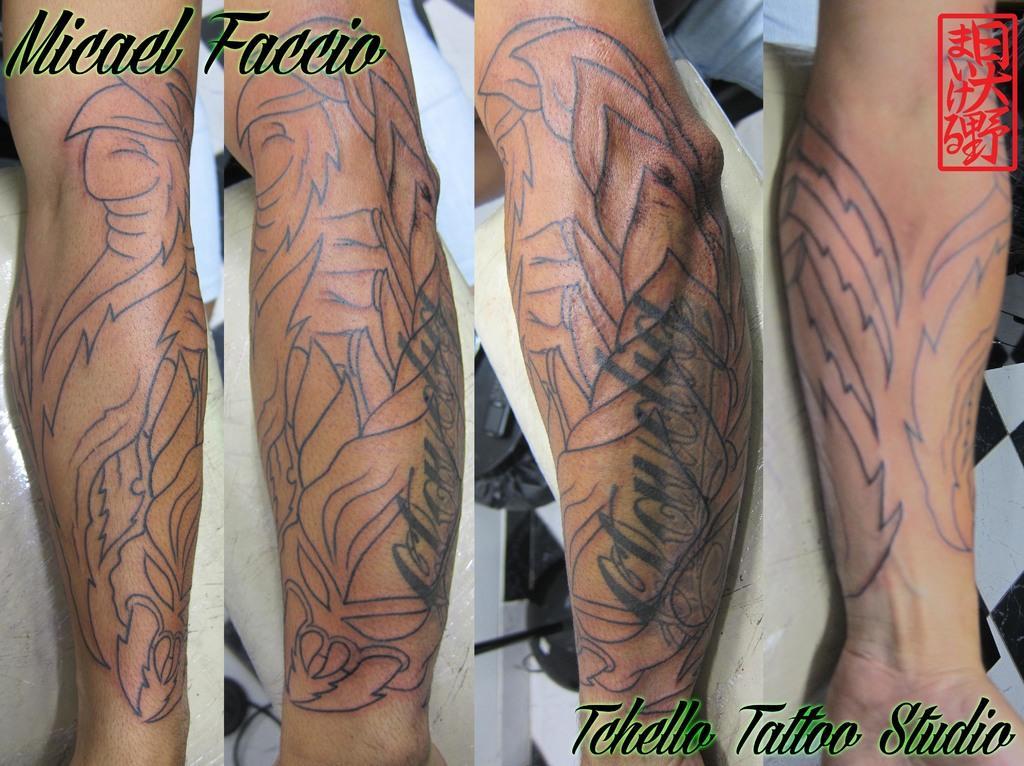How would you summarize this image in a sentence or two? In this image I can see the collage picture. I can see few tattoos on four hands and something is written on the image. 